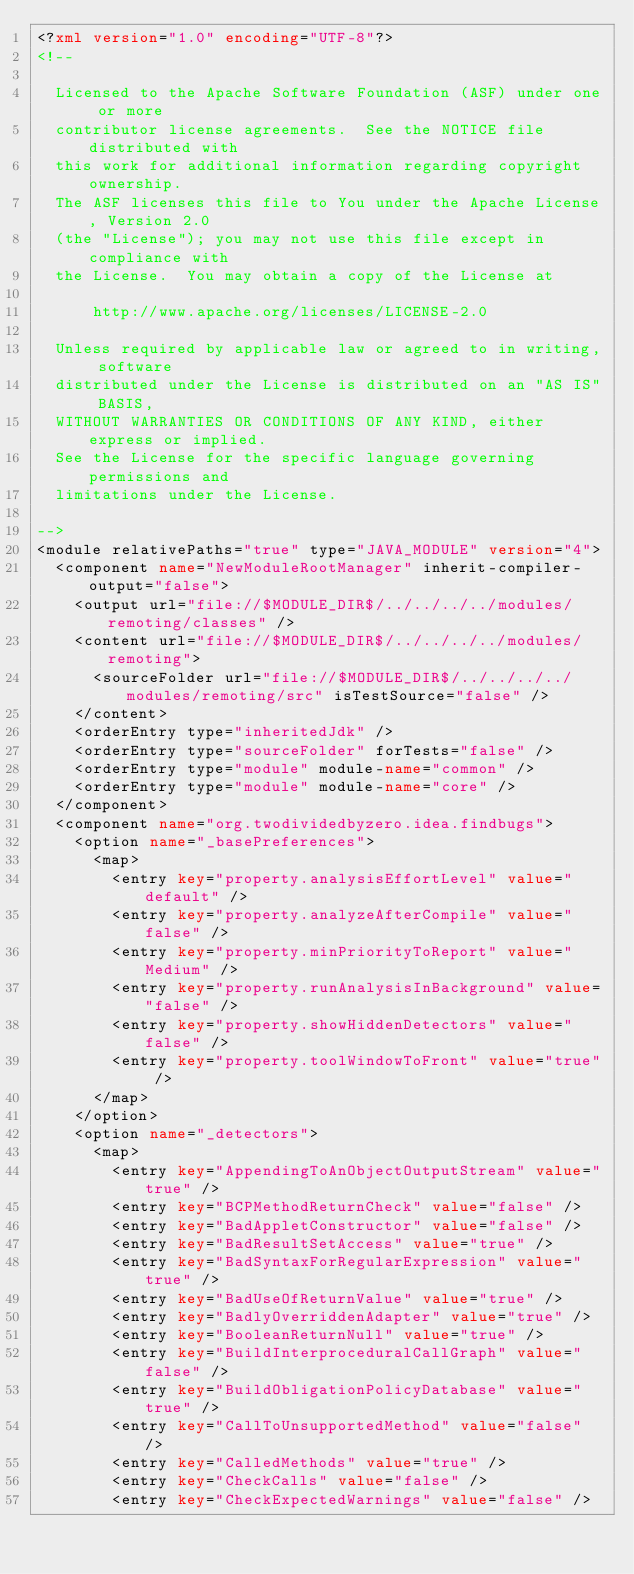<code> <loc_0><loc_0><loc_500><loc_500><_XML_><?xml version="1.0" encoding="UTF-8"?>
<!--

  Licensed to the Apache Software Foundation (ASF) under one or more
  contributor license agreements.  See the NOTICE file distributed with
  this work for additional information regarding copyright ownership.
  The ASF licenses this file to You under the Apache License, Version 2.0
  (the "License"); you may not use this file except in compliance with
  the License.  You may obtain a copy of the License at

      http://www.apache.org/licenses/LICENSE-2.0

  Unless required by applicable law or agreed to in writing, software
  distributed under the License is distributed on an "AS IS" BASIS,
  WITHOUT WARRANTIES OR CONDITIONS OF ANY KIND, either express or implied.
  See the License for the specific language governing permissions and
  limitations under the License.

-->
<module relativePaths="true" type="JAVA_MODULE" version="4">
  <component name="NewModuleRootManager" inherit-compiler-output="false">
    <output url="file://$MODULE_DIR$/../../../../modules/remoting/classes" />
    <content url="file://$MODULE_DIR$/../../../../modules/remoting">
      <sourceFolder url="file://$MODULE_DIR$/../../../../modules/remoting/src" isTestSource="false" />
    </content>
    <orderEntry type="inheritedJdk" />
    <orderEntry type="sourceFolder" forTests="false" />
    <orderEntry type="module" module-name="common" />
    <orderEntry type="module" module-name="core" />
  </component>
  <component name="org.twodividedbyzero.idea.findbugs">
    <option name="_basePreferences">
      <map>
        <entry key="property.analysisEffortLevel" value="default" />
        <entry key="property.analyzeAfterCompile" value="false" />
        <entry key="property.minPriorityToReport" value="Medium" />
        <entry key="property.runAnalysisInBackground" value="false" />
        <entry key="property.showHiddenDetectors" value="false" />
        <entry key="property.toolWindowToFront" value="true" />
      </map>
    </option>
    <option name="_detectors">
      <map>
        <entry key="AppendingToAnObjectOutputStream" value="true" />
        <entry key="BCPMethodReturnCheck" value="false" />
        <entry key="BadAppletConstructor" value="false" />
        <entry key="BadResultSetAccess" value="true" />
        <entry key="BadSyntaxForRegularExpression" value="true" />
        <entry key="BadUseOfReturnValue" value="true" />
        <entry key="BadlyOverriddenAdapter" value="true" />
        <entry key="BooleanReturnNull" value="true" />
        <entry key="BuildInterproceduralCallGraph" value="false" />
        <entry key="BuildObligationPolicyDatabase" value="true" />
        <entry key="CallToUnsupportedMethod" value="false" />
        <entry key="CalledMethods" value="true" />
        <entry key="CheckCalls" value="false" />
        <entry key="CheckExpectedWarnings" value="false" /></code> 